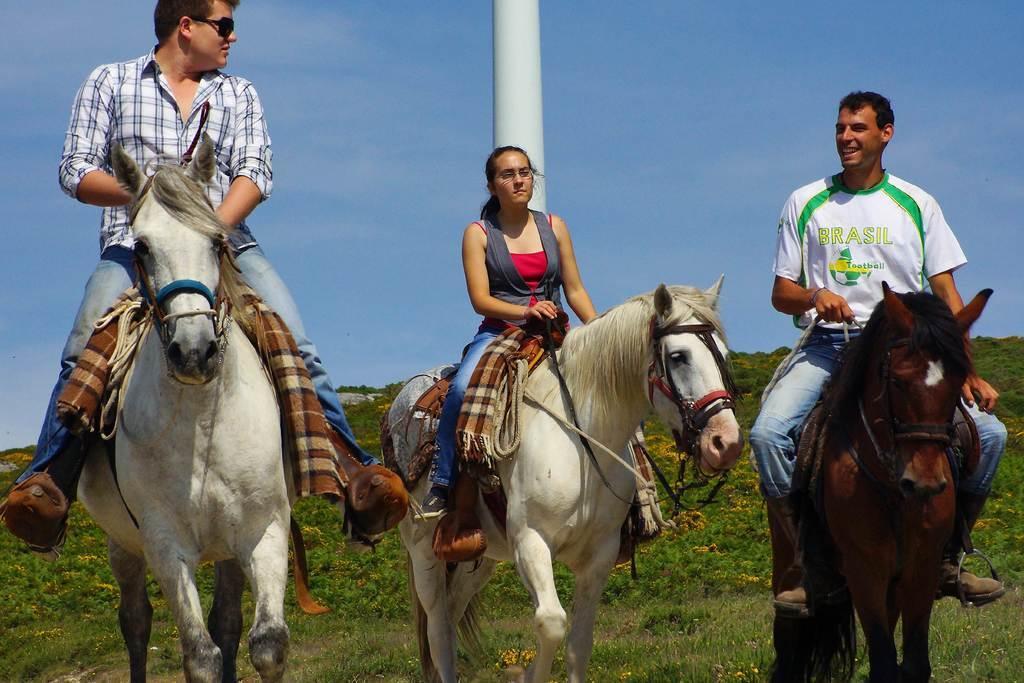Could you give a brief overview of what you see in this image? In this image there are three people sitting on the horses. Behind them there is a pole. At the bottom of the image there are plants and flowers. At the top of the image there is sky. 